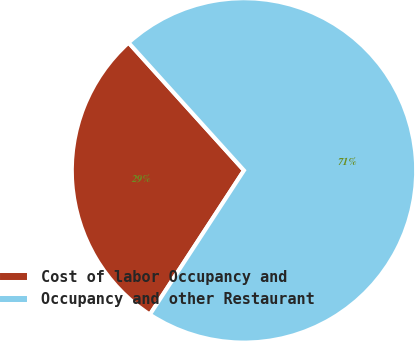<chart> <loc_0><loc_0><loc_500><loc_500><pie_chart><fcel>Cost of labor Occupancy and<fcel>Occupancy and other Restaurant<nl><fcel>29.1%<fcel>70.9%<nl></chart> 